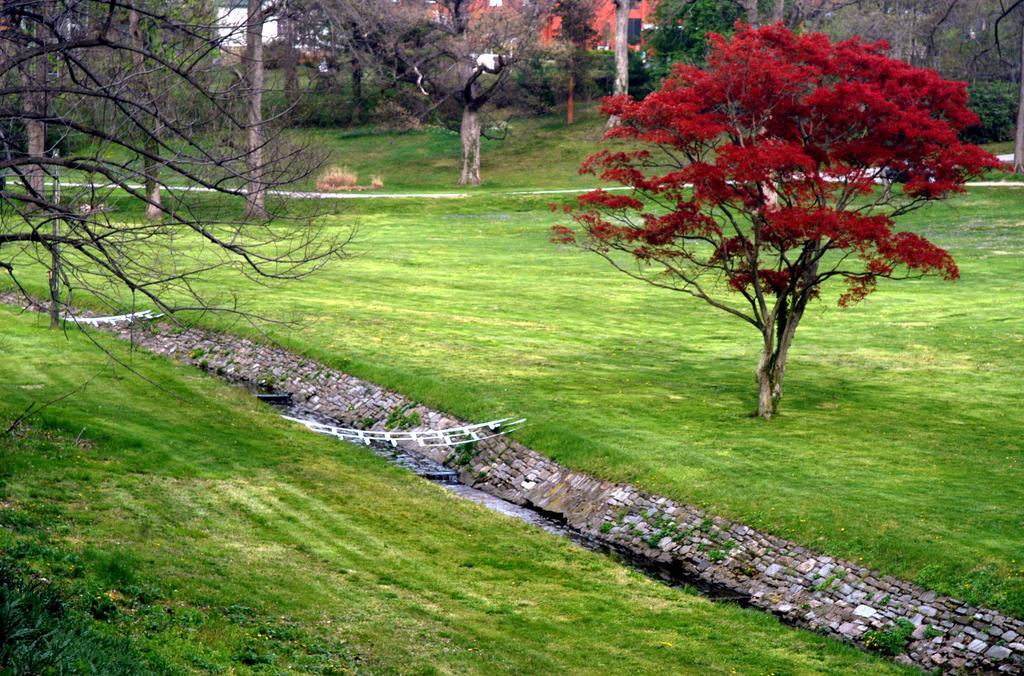Could you give a brief overview of what you see in this image? This image is clicked outside. There are trees in the middle. There is grass at the bottom. There are buildings at the top. 